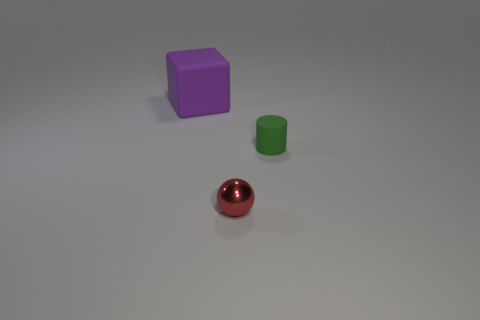Are there fewer large purple matte things that are to the right of the sphere than tiny rubber cylinders?
Make the answer very short. Yes. Are there any things that have the same material as the tiny green cylinder?
Ensure brevity in your answer.  Yes. There is a sphere that is the same size as the green rubber object; what material is it?
Provide a short and direct response. Metal. Is the number of large matte things that are in front of the small rubber thing less than the number of green things that are in front of the purple rubber object?
Give a very brief answer. Yes. There is a thing that is both left of the green rubber object and on the right side of the purple thing; what shape is it?
Keep it short and to the point. Sphere. How many big purple objects have the same shape as the red object?
Offer a terse response. 0. There is another thing that is made of the same material as the large purple thing; what size is it?
Make the answer very short. Small. Are there more tiny purple metallic things than large purple cubes?
Keep it short and to the point. No. The rubber thing on the right side of the large cube is what color?
Your answer should be compact. Green. There is a object that is both to the left of the green thing and behind the red shiny ball; what size is it?
Your answer should be compact. Large. 